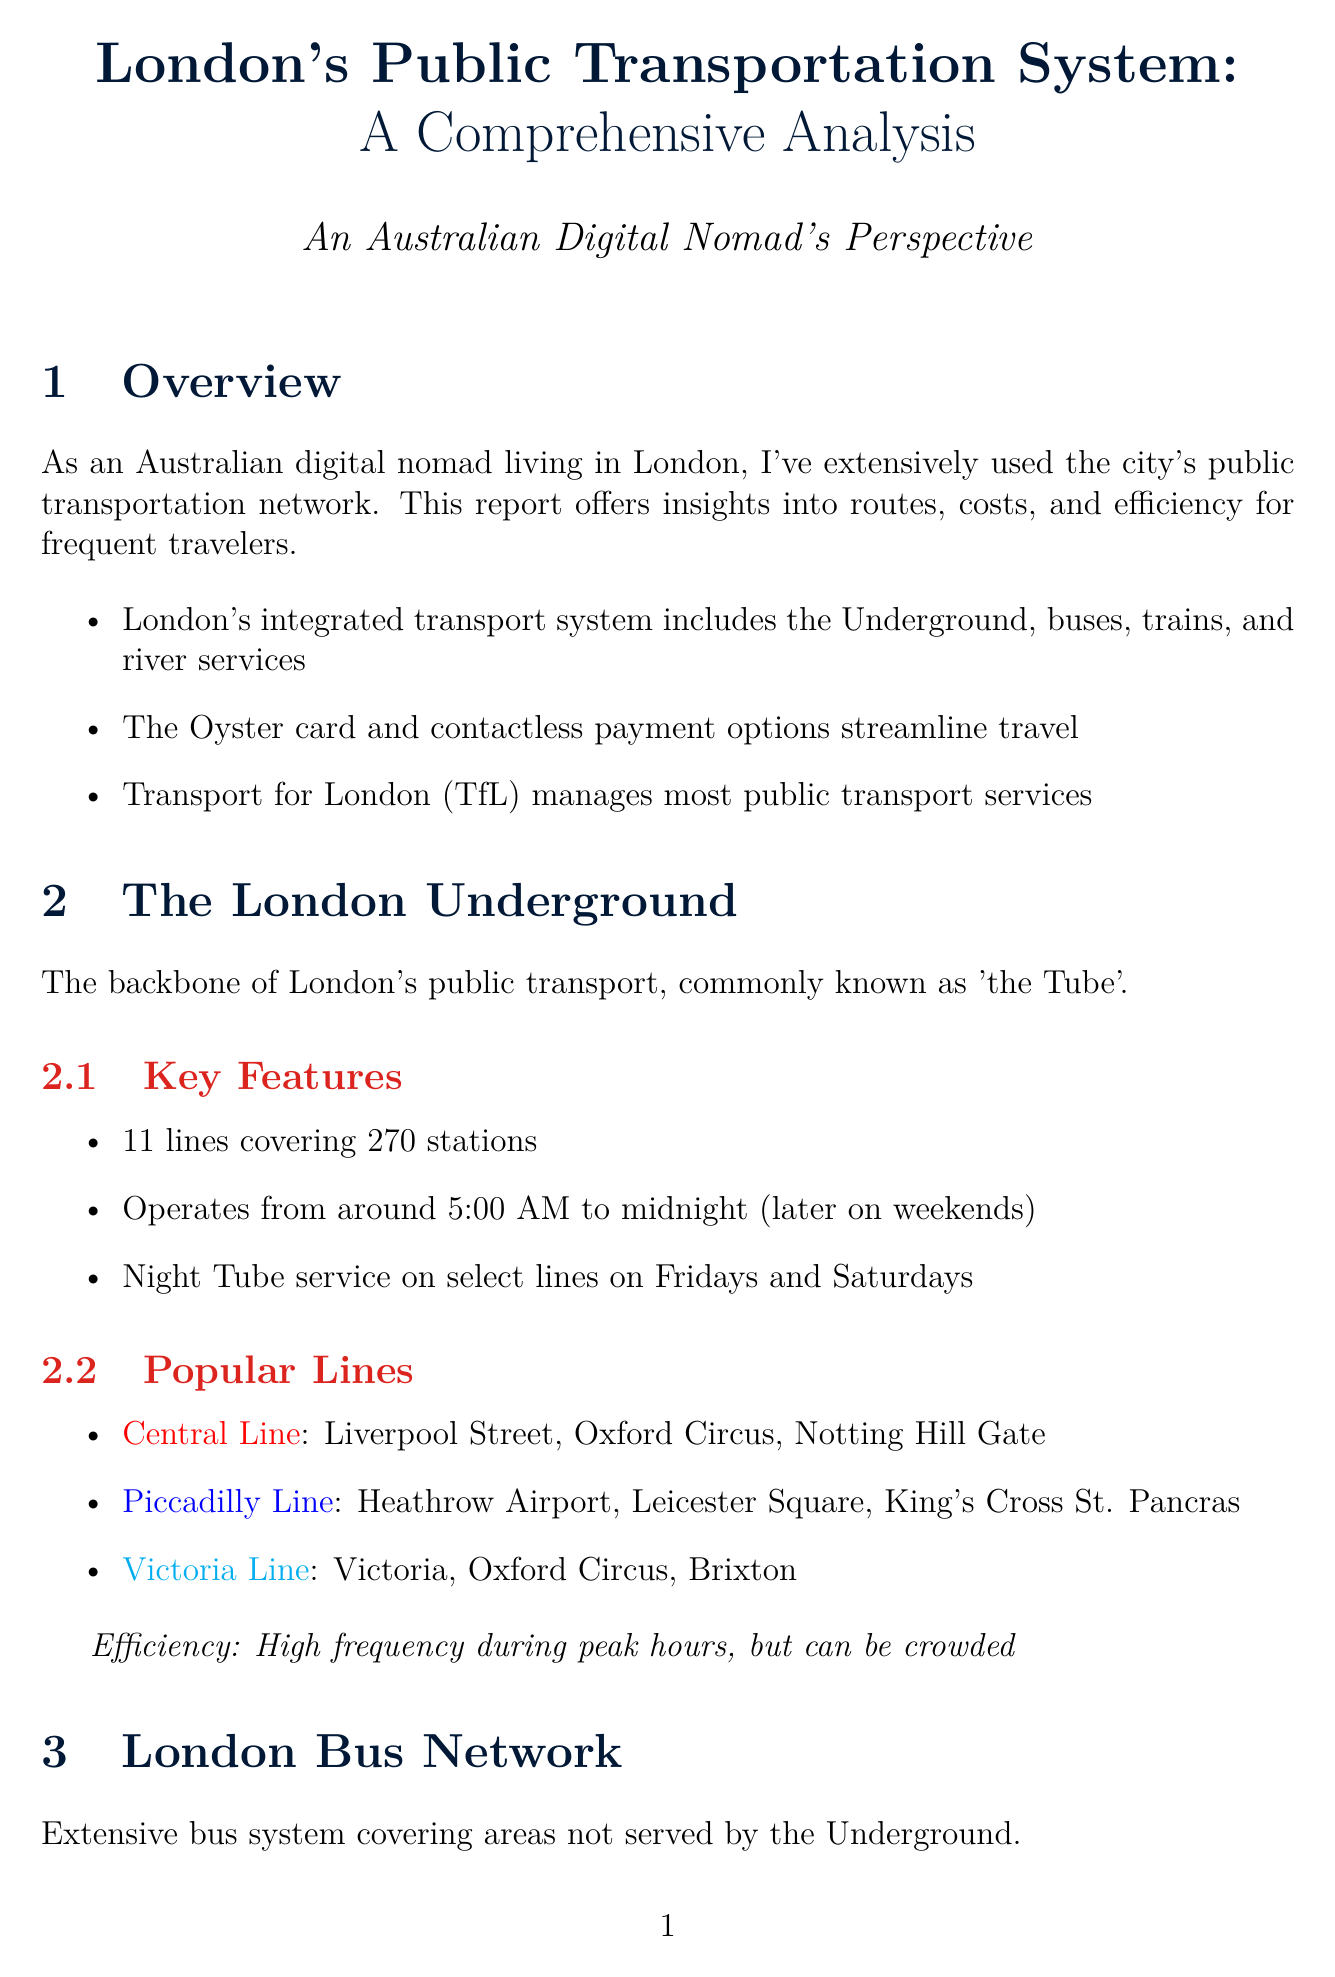What is the title of the report? The title of the report is presented in the opening section as the main topic of analysis.
Answer: London's Public Transportation System: A Comprehensive Analysis How many lines does the London Underground have? The document specifies the number of lines within the London Underground section.
Answer: 11 What color is the Piccadilly Line? The color of the Piccadilly Line is related to its visual representation in the document.
Answer: Dark Blue What is the price of a Monthly Travelcard for Zones 1-3? The document lists fare prices for different travelcards, providing specific pricing information.
Answer: £167.10 Which service operates from Putney to Woolwich? The answer can be found in the section describing river services, summarizing its operational routes.
Answer: Thames Clippers What is the score for the Underground in the efficiency comparison? The score for the Underground is presented in the efficiency analysis section, reflecting its performance for travelers.
Answer: 9 What is a recommended tip for frequent travelers? The tips section provides advice based on the author's experiences for navigating the transport system efficiently.
Answer: Download the Citymapper app for real-time journey planning Which payment method is integrated with the Oyster card system? This payment method is specifically mentioned in relation to the fare structure and integration with the system.
Answer: Mobile payments (Apple Pay, Google Pay) How many bus routes are there in the London Bus Network? This information is directly cited in the bus section, showcasing the extent of the bus system in London.
Answer: Over 700 